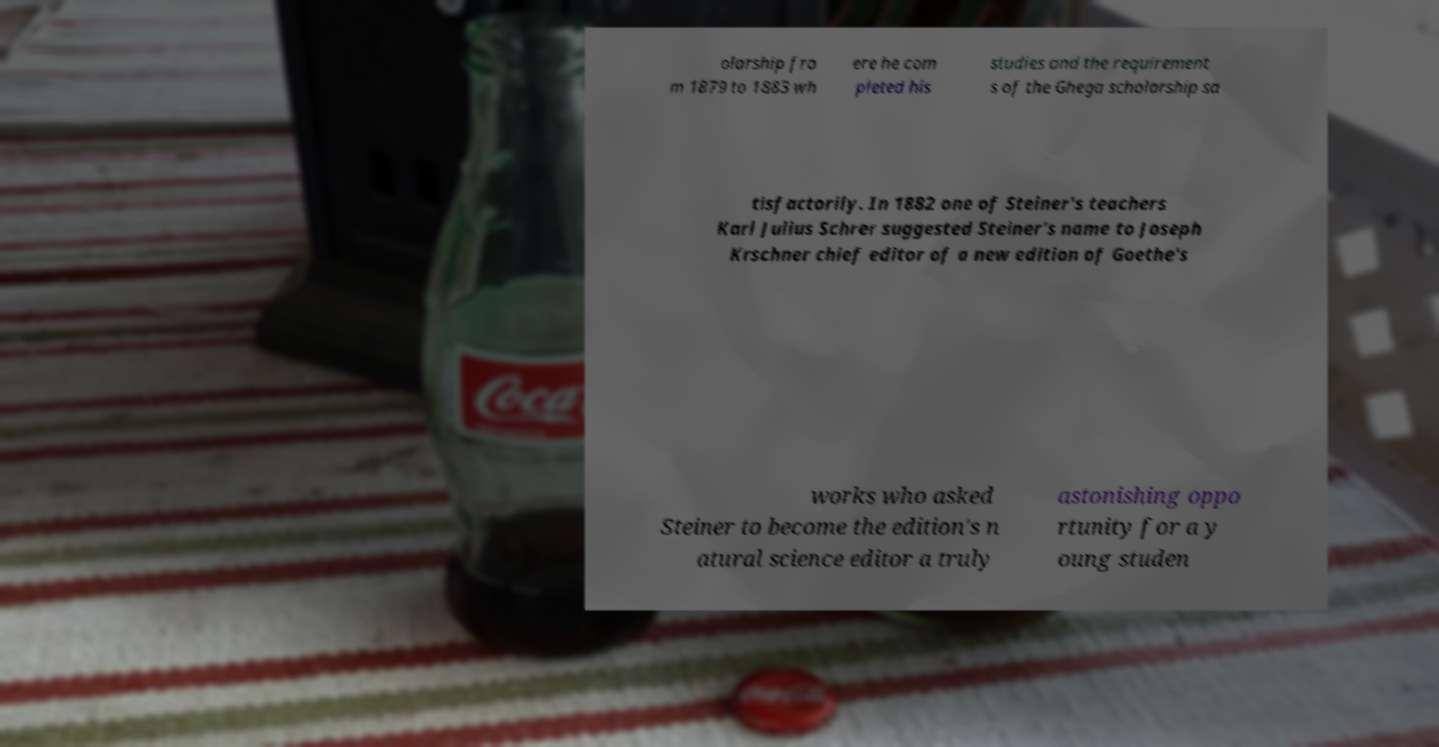I need the written content from this picture converted into text. Can you do that? olarship fro m 1879 to 1883 wh ere he com pleted his studies and the requirement s of the Ghega scholarship sa tisfactorily. In 1882 one of Steiner's teachers Karl Julius Schrer suggested Steiner's name to Joseph Krschner chief editor of a new edition of Goethe's works who asked Steiner to become the edition's n atural science editor a truly astonishing oppo rtunity for a y oung studen 